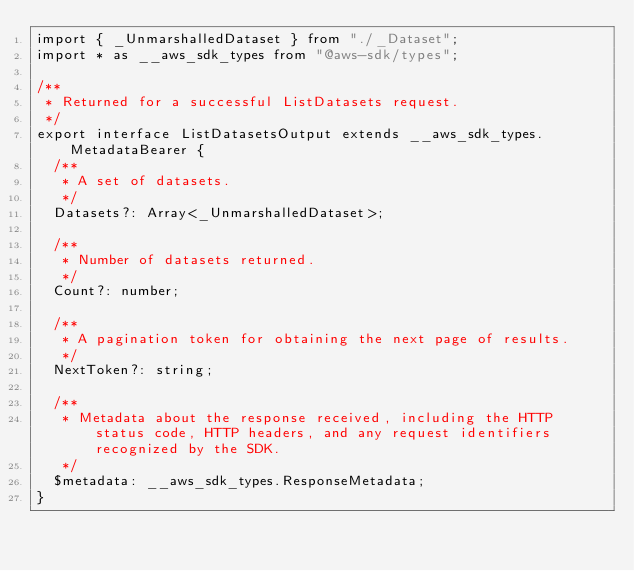<code> <loc_0><loc_0><loc_500><loc_500><_TypeScript_>import { _UnmarshalledDataset } from "./_Dataset";
import * as __aws_sdk_types from "@aws-sdk/types";

/**
 * Returned for a successful ListDatasets request.
 */
export interface ListDatasetsOutput extends __aws_sdk_types.MetadataBearer {
  /**
   * A set of datasets.
   */
  Datasets?: Array<_UnmarshalledDataset>;

  /**
   * Number of datasets returned.
   */
  Count?: number;

  /**
   * A pagination token for obtaining the next page of results.
   */
  NextToken?: string;

  /**
   * Metadata about the response received, including the HTTP status code, HTTP headers, and any request identifiers recognized by the SDK.
   */
  $metadata: __aws_sdk_types.ResponseMetadata;
}
</code> 